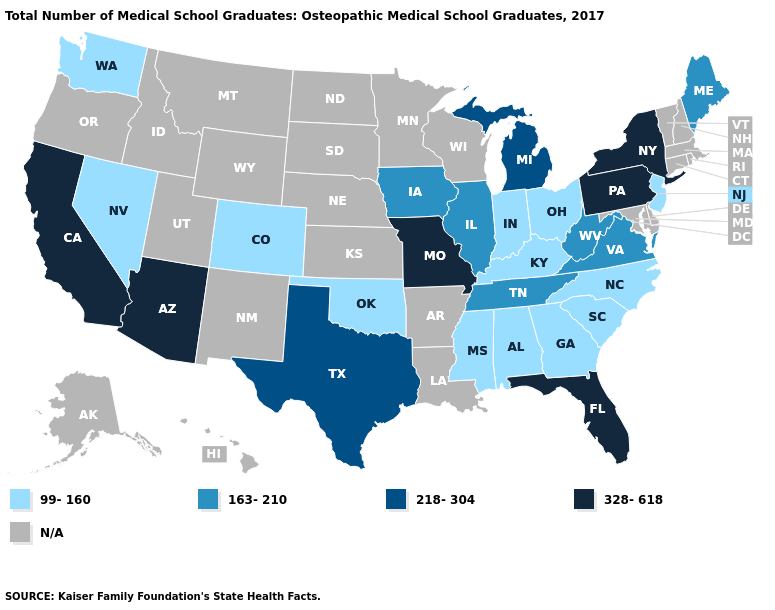What is the value of Arizona?
Be succinct. 328-618. Does Missouri have the lowest value in the MidWest?
Give a very brief answer. No. Is the legend a continuous bar?
Short answer required. No. What is the lowest value in the South?
Quick response, please. 99-160. Which states have the highest value in the USA?
Quick response, please. Arizona, California, Florida, Missouri, New York, Pennsylvania. How many symbols are there in the legend?
Concise answer only. 5. Among the states that border Arizona , which have the lowest value?
Keep it brief. Colorado, Nevada. Name the states that have a value in the range 99-160?
Short answer required. Alabama, Colorado, Georgia, Indiana, Kentucky, Mississippi, Nevada, New Jersey, North Carolina, Ohio, Oklahoma, South Carolina, Washington. What is the value of Missouri?
Short answer required. 328-618. Name the states that have a value in the range N/A?
Concise answer only. Alaska, Arkansas, Connecticut, Delaware, Hawaii, Idaho, Kansas, Louisiana, Maryland, Massachusetts, Minnesota, Montana, Nebraska, New Hampshire, New Mexico, North Dakota, Oregon, Rhode Island, South Dakota, Utah, Vermont, Wisconsin, Wyoming. What is the value of New Hampshire?
Quick response, please. N/A. Does the first symbol in the legend represent the smallest category?
Short answer required. Yes. Which states have the lowest value in the Northeast?
Concise answer only. New Jersey. 